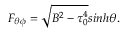<formula> <loc_0><loc_0><loc_500><loc_500>F _ { \theta \phi } = \sqrt { B ^ { 2 } - \tau _ { 0 } ^ { 4 } } \sinh \theta .</formula> 